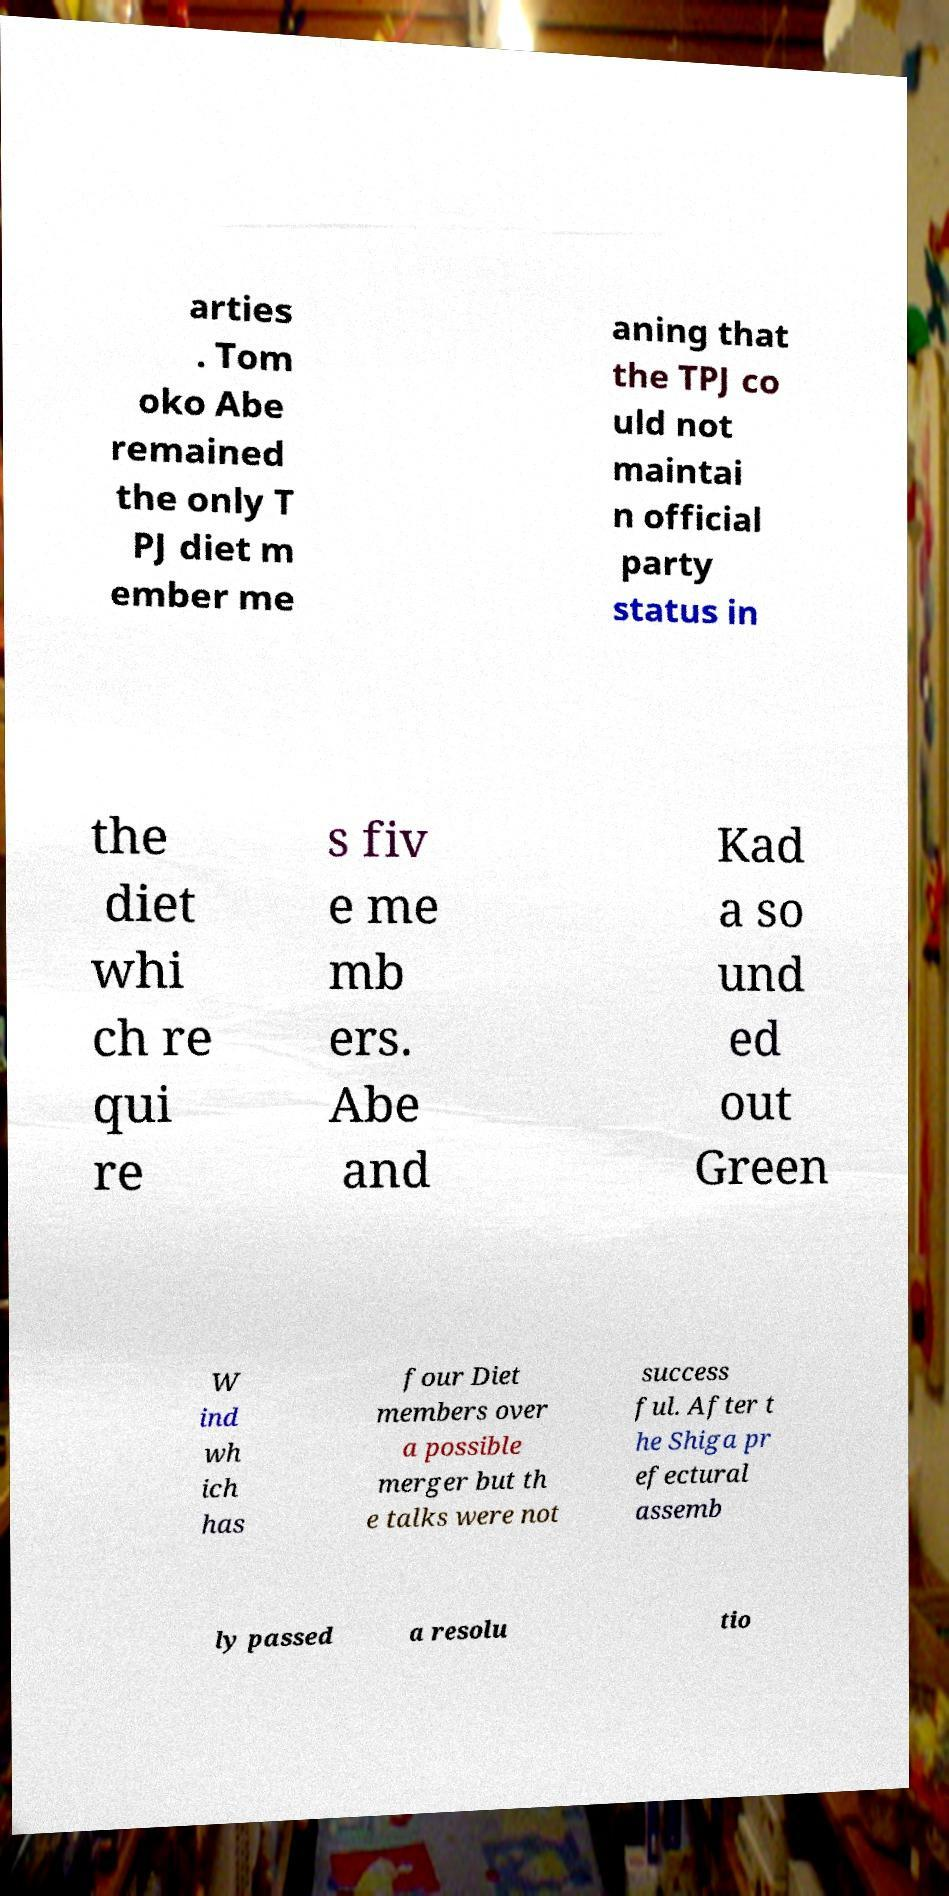Could you assist in decoding the text presented in this image and type it out clearly? arties . Tom oko Abe remained the only T PJ diet m ember me aning that the TPJ co uld not maintai n official party status in the diet whi ch re qui re s fiv e me mb ers. Abe and Kad a so und ed out Green W ind wh ich has four Diet members over a possible merger but th e talks were not success ful. After t he Shiga pr efectural assemb ly passed a resolu tio 